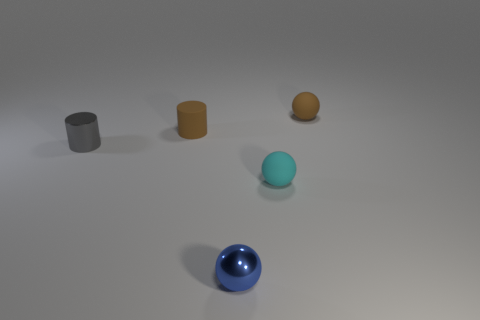Subtract all brown cylinders. Subtract all blue balls. How many cylinders are left? 1 Add 2 small brown rubber cylinders. How many objects exist? 7 Subtract all balls. How many objects are left? 2 Add 3 tiny brown spheres. How many tiny brown spheres are left? 4 Add 5 matte cylinders. How many matte cylinders exist? 6 Subtract 0 yellow cylinders. How many objects are left? 5 Subtract all small red matte balls. Subtract all tiny brown matte cylinders. How many objects are left? 4 